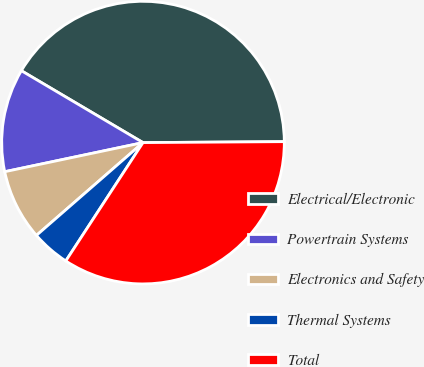Convert chart to OTSL. <chart><loc_0><loc_0><loc_500><loc_500><pie_chart><fcel>Electrical/Electronic<fcel>Powertrain Systems<fcel>Electronics and Safety<fcel>Thermal Systems<fcel>Total<nl><fcel>41.4%<fcel>11.8%<fcel>8.1%<fcel>4.4%<fcel>34.31%<nl></chart> 